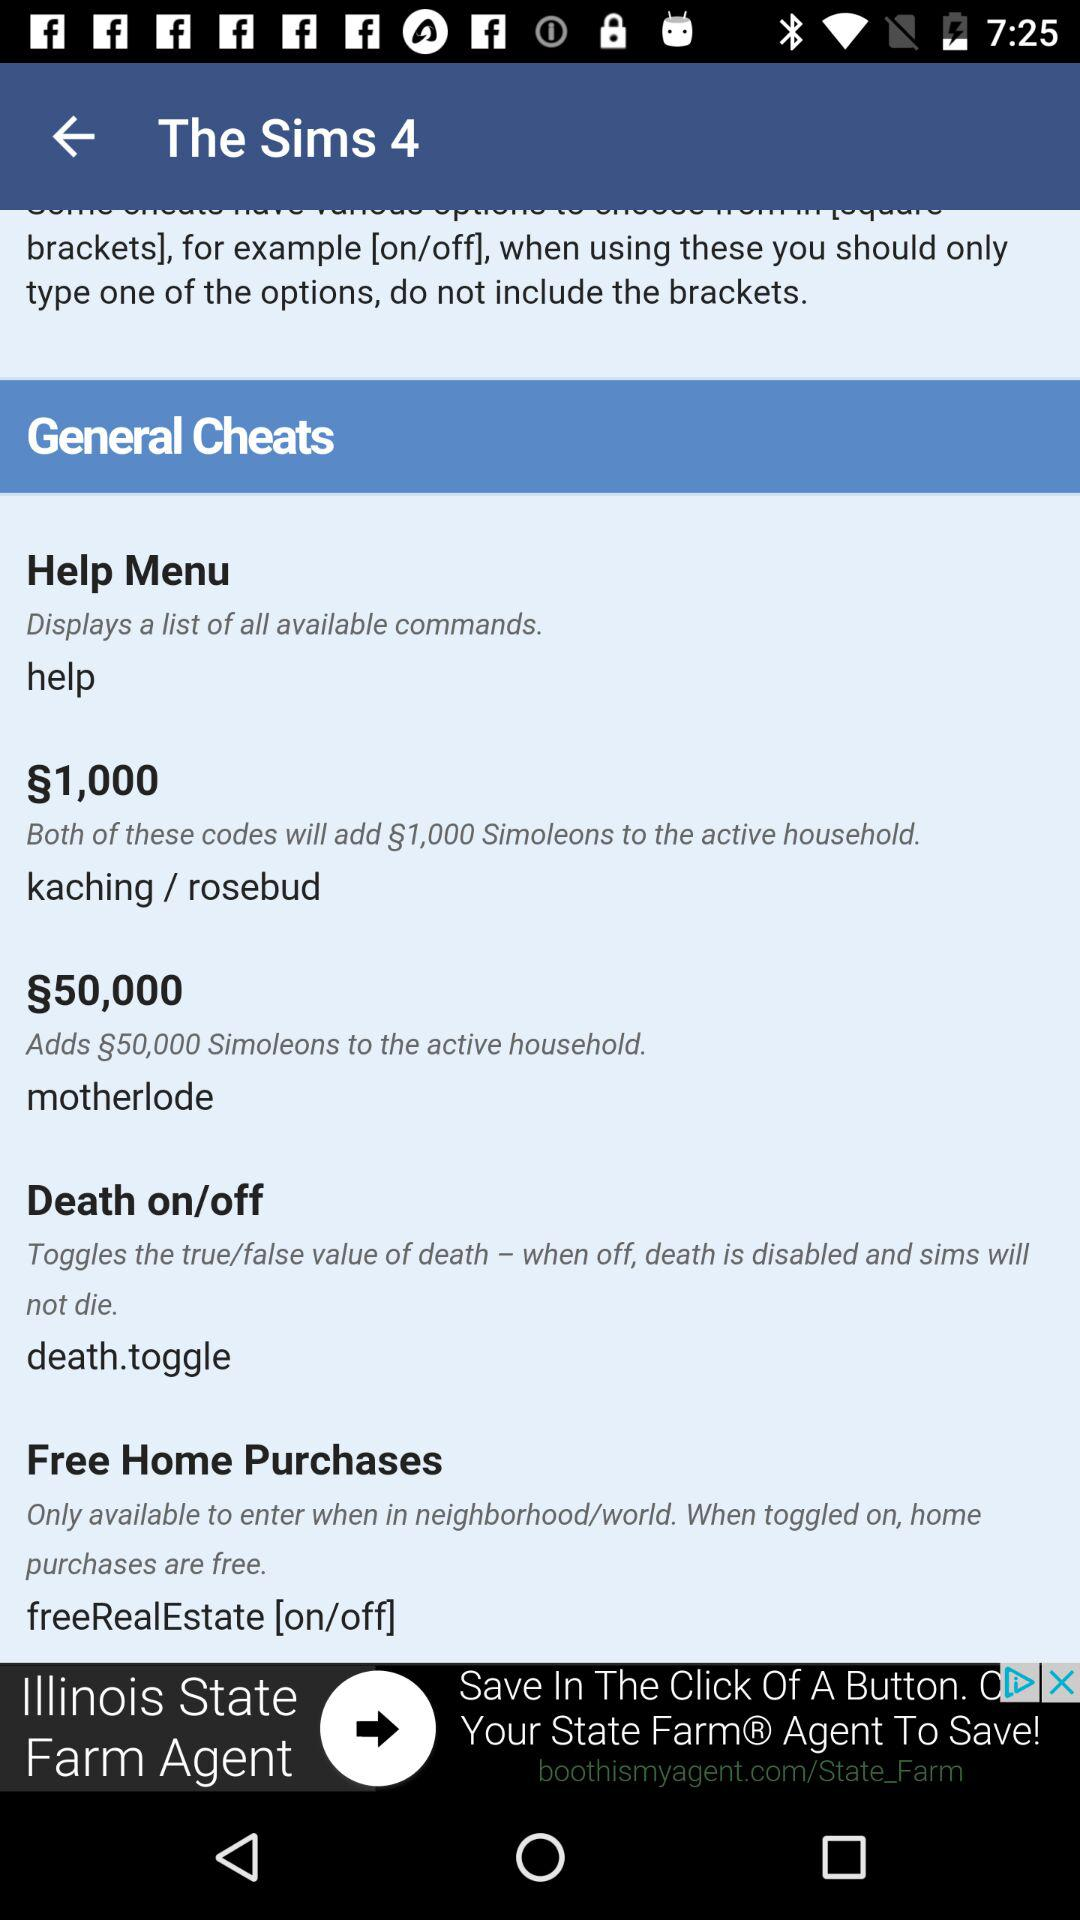How much value is required for the active household?
When the provided information is insufficient, respond with <no answer>. <no answer> 